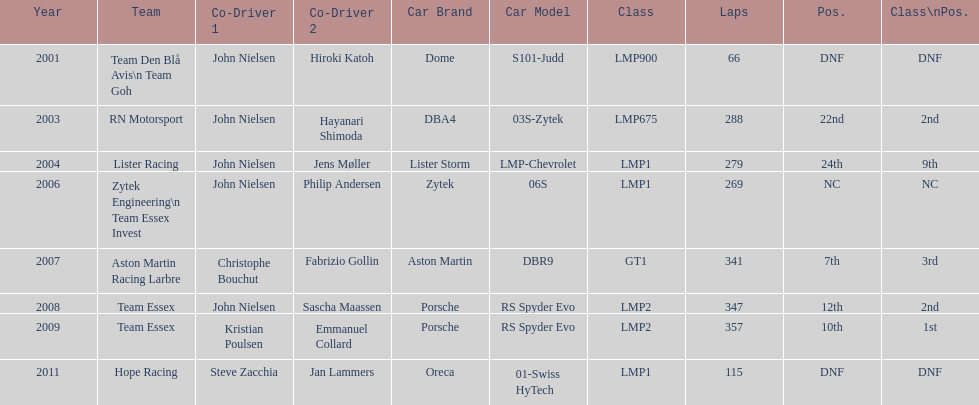How many times was the final position above 20? 2. 